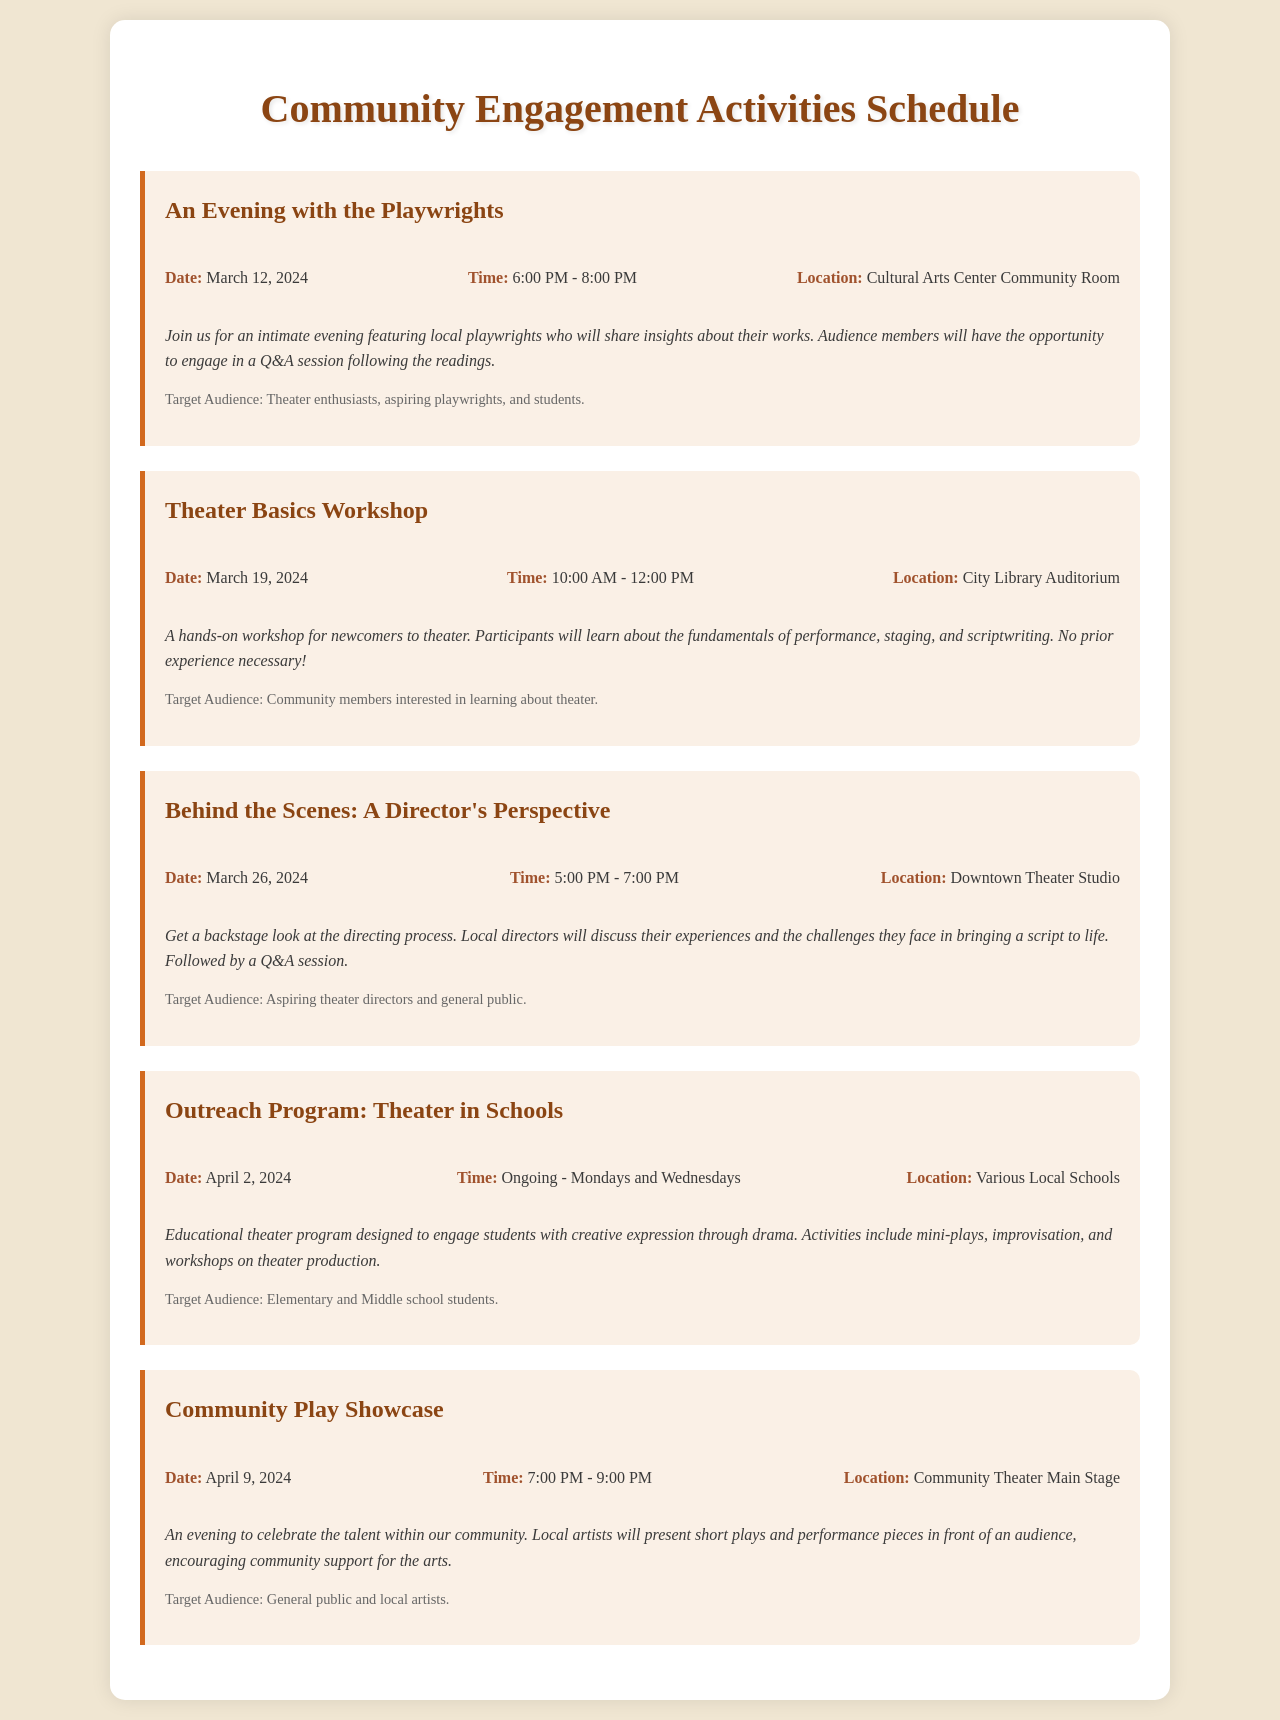What is the date of the "An Evening with the Playwrights" event? The date is specified in the details of the event as March 12, 2024.
Answer: March 12, 2024 What time does the "Theater Basics Workshop" start? The start time is listed in the event details as 10:00 AM.
Answer: 10:00 AM Who is the target audience for the "Behind the Scenes: A Director's Perspective"? The target audience is provided in the document as aspiring theater directors and the general public.
Answer: Aspiring theater directors and general public What is the location for the "Community Play Showcase"? The location is stated in the event details as Community Theater Main Stage.
Answer: Community Theater Main Stage How often does the "Outreach Program: Theater in Schools" occur? It mentions in the document that it is ongoing on Mondays and Wednesdays.
Answer: Mondays and Wednesdays What type of activities are involved in the "Outreach Program: Theater in Schools"? The document lists mini-plays, improvisation, and workshops on theater production as activities in the program.
Answer: Mini-plays, improvisation, and workshops on theater production What is the duration of the "An Evening with the Playwrights"? The duration is inferred by subtracting the starting time from the ending time in the event details, which is a two-hour event from 6:00 PM to 8:00 PM.
Answer: 2 hours Which event provides insights about local playwrights? The description specifies that "An Evening with the Playwrights" features local playwrights sharing insights.
Answer: An Evening with the Playwrights What is the overall theme of the Community Engagement Activities? The events focus on promoting theater literacy among local audiences through various engagement activities.
Answer: Theater literacy 